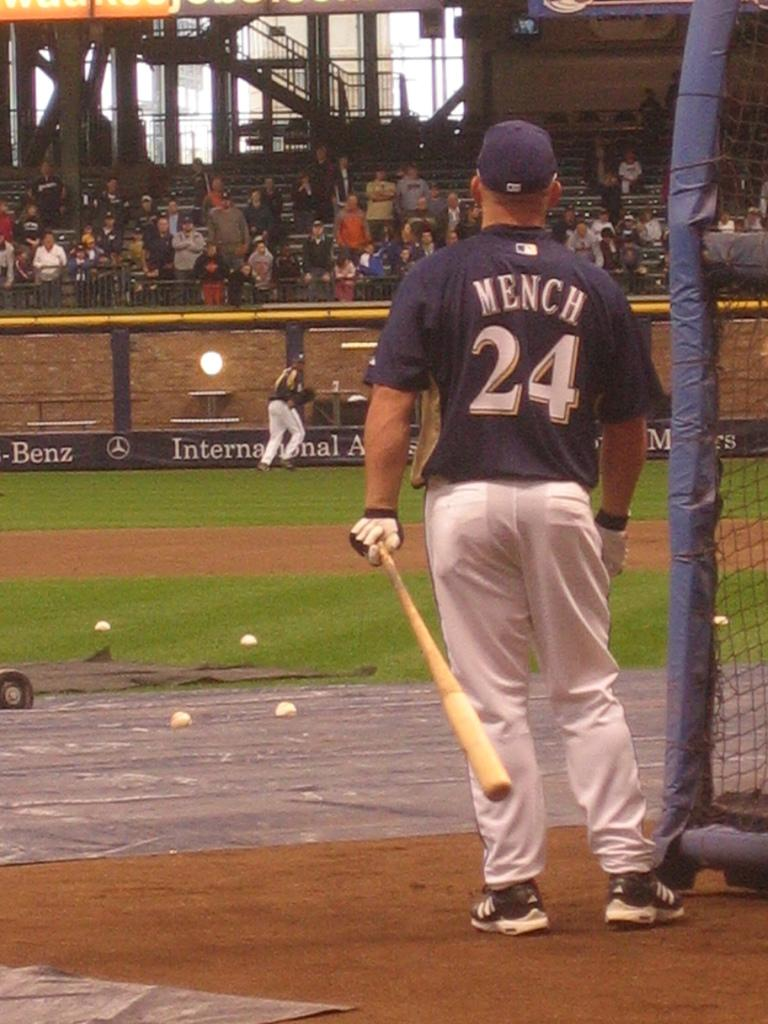<image>
Present a compact description of the photo's key features. a man with a baseball jersey on that says Mench 